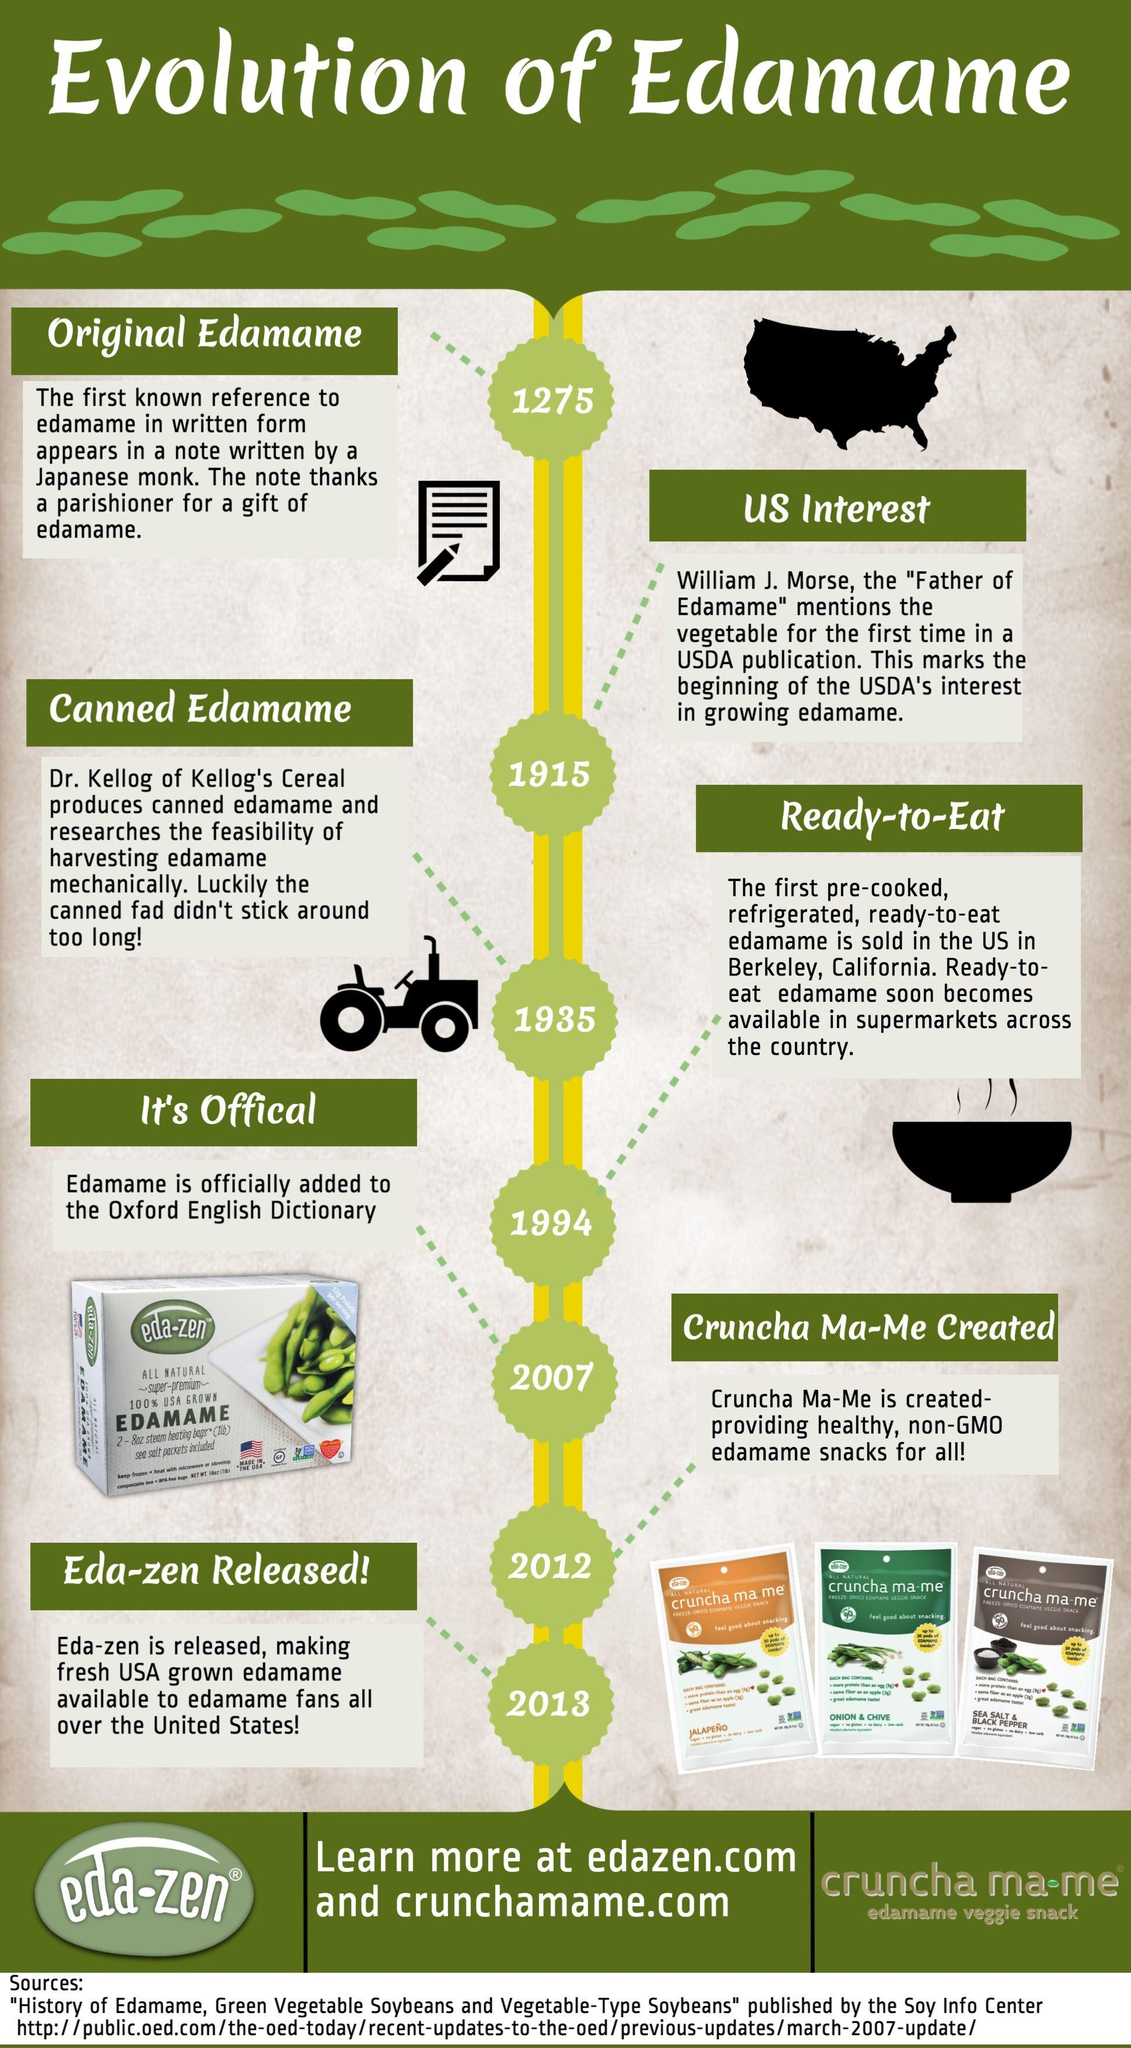Mention a couple of crucial points in this snapshot. The green pack of Cruncha Ma-Me is flavored with onion and chive. The name "Edamame" was added to the dictionary in 2007. Eda-Zen was released in 2007, 2013, or 2012. It was released in 2013. The name "Edamame" was first mentioned in 1935, 1275, 2013, or 1994. Cruncha Ma-Me brown pack is a delicious combination of sea salt and black pepper that imparts a unique and intriguing flavor to any dish. 